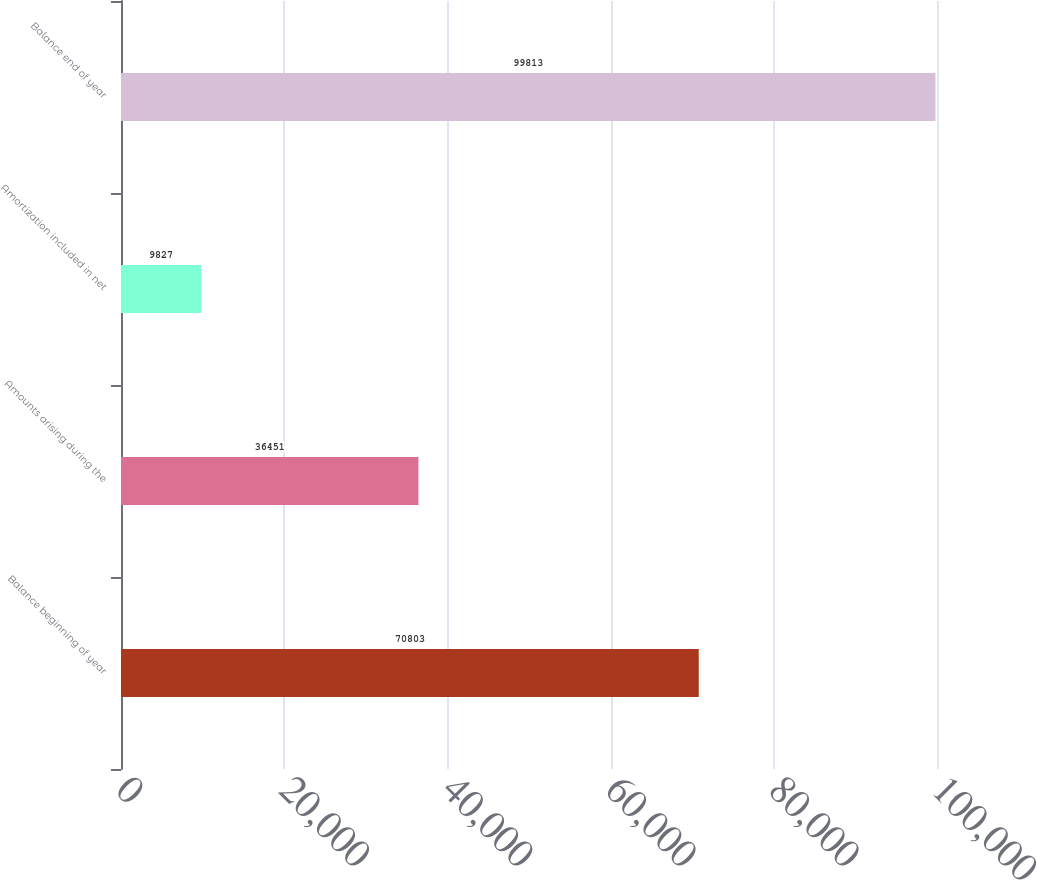<chart> <loc_0><loc_0><loc_500><loc_500><bar_chart><fcel>Balance beginning of year<fcel>Amounts arising during the<fcel>Amortization included in net<fcel>Balance end of year<nl><fcel>70803<fcel>36451<fcel>9827<fcel>99813<nl></chart> 